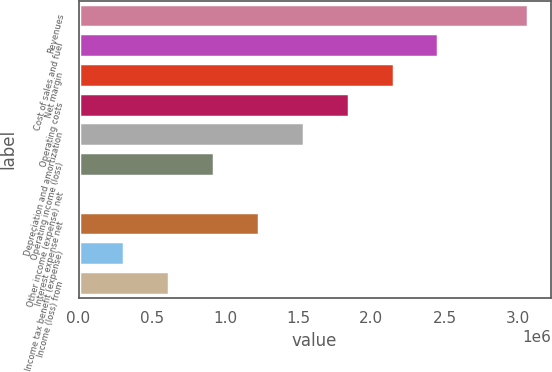Convert chart. <chart><loc_0><loc_0><loc_500><loc_500><bar_chart><fcel>Revenues<fcel>Cost of sales and fuel<fcel>Net margin<fcel>Operating costs<fcel>Depreciation and amortization<fcel>Operating income (loss)<fcel>Other income (expense) net<fcel>Interest expense net<fcel>Income tax benefit (expense)<fcel>Income (loss) from<nl><fcel>3.07158e+06<fcel>2.45779e+06<fcel>2.15089e+06<fcel>1.844e+06<fcel>1.5371e+06<fcel>923308<fcel>2619<fcel>1.2302e+06<fcel>309515<fcel>616411<nl></chart> 